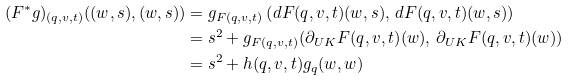<formula> <loc_0><loc_0><loc_500><loc_500>( F ^ { * } g ) _ { ( q , v , t ) } ( ( w , s ) , ( w , s ) ) & = g _ { F ( q , v , t ) } \left ( d F ( q , v , t ) ( w , s ) , \, d F ( q , v , t ) ( w , s ) \right ) \\ & = s ^ { 2 } + g _ { F ( q , v , t ) } ( \partial _ { U K } F { ( q , v , t ) } ( w ) , \, \partial _ { U K } F { ( q , v , t ) } ( w ) ) \\ & = s ^ { 2 } + h ( q , v , t ) g _ { q } ( w , w )</formula> 